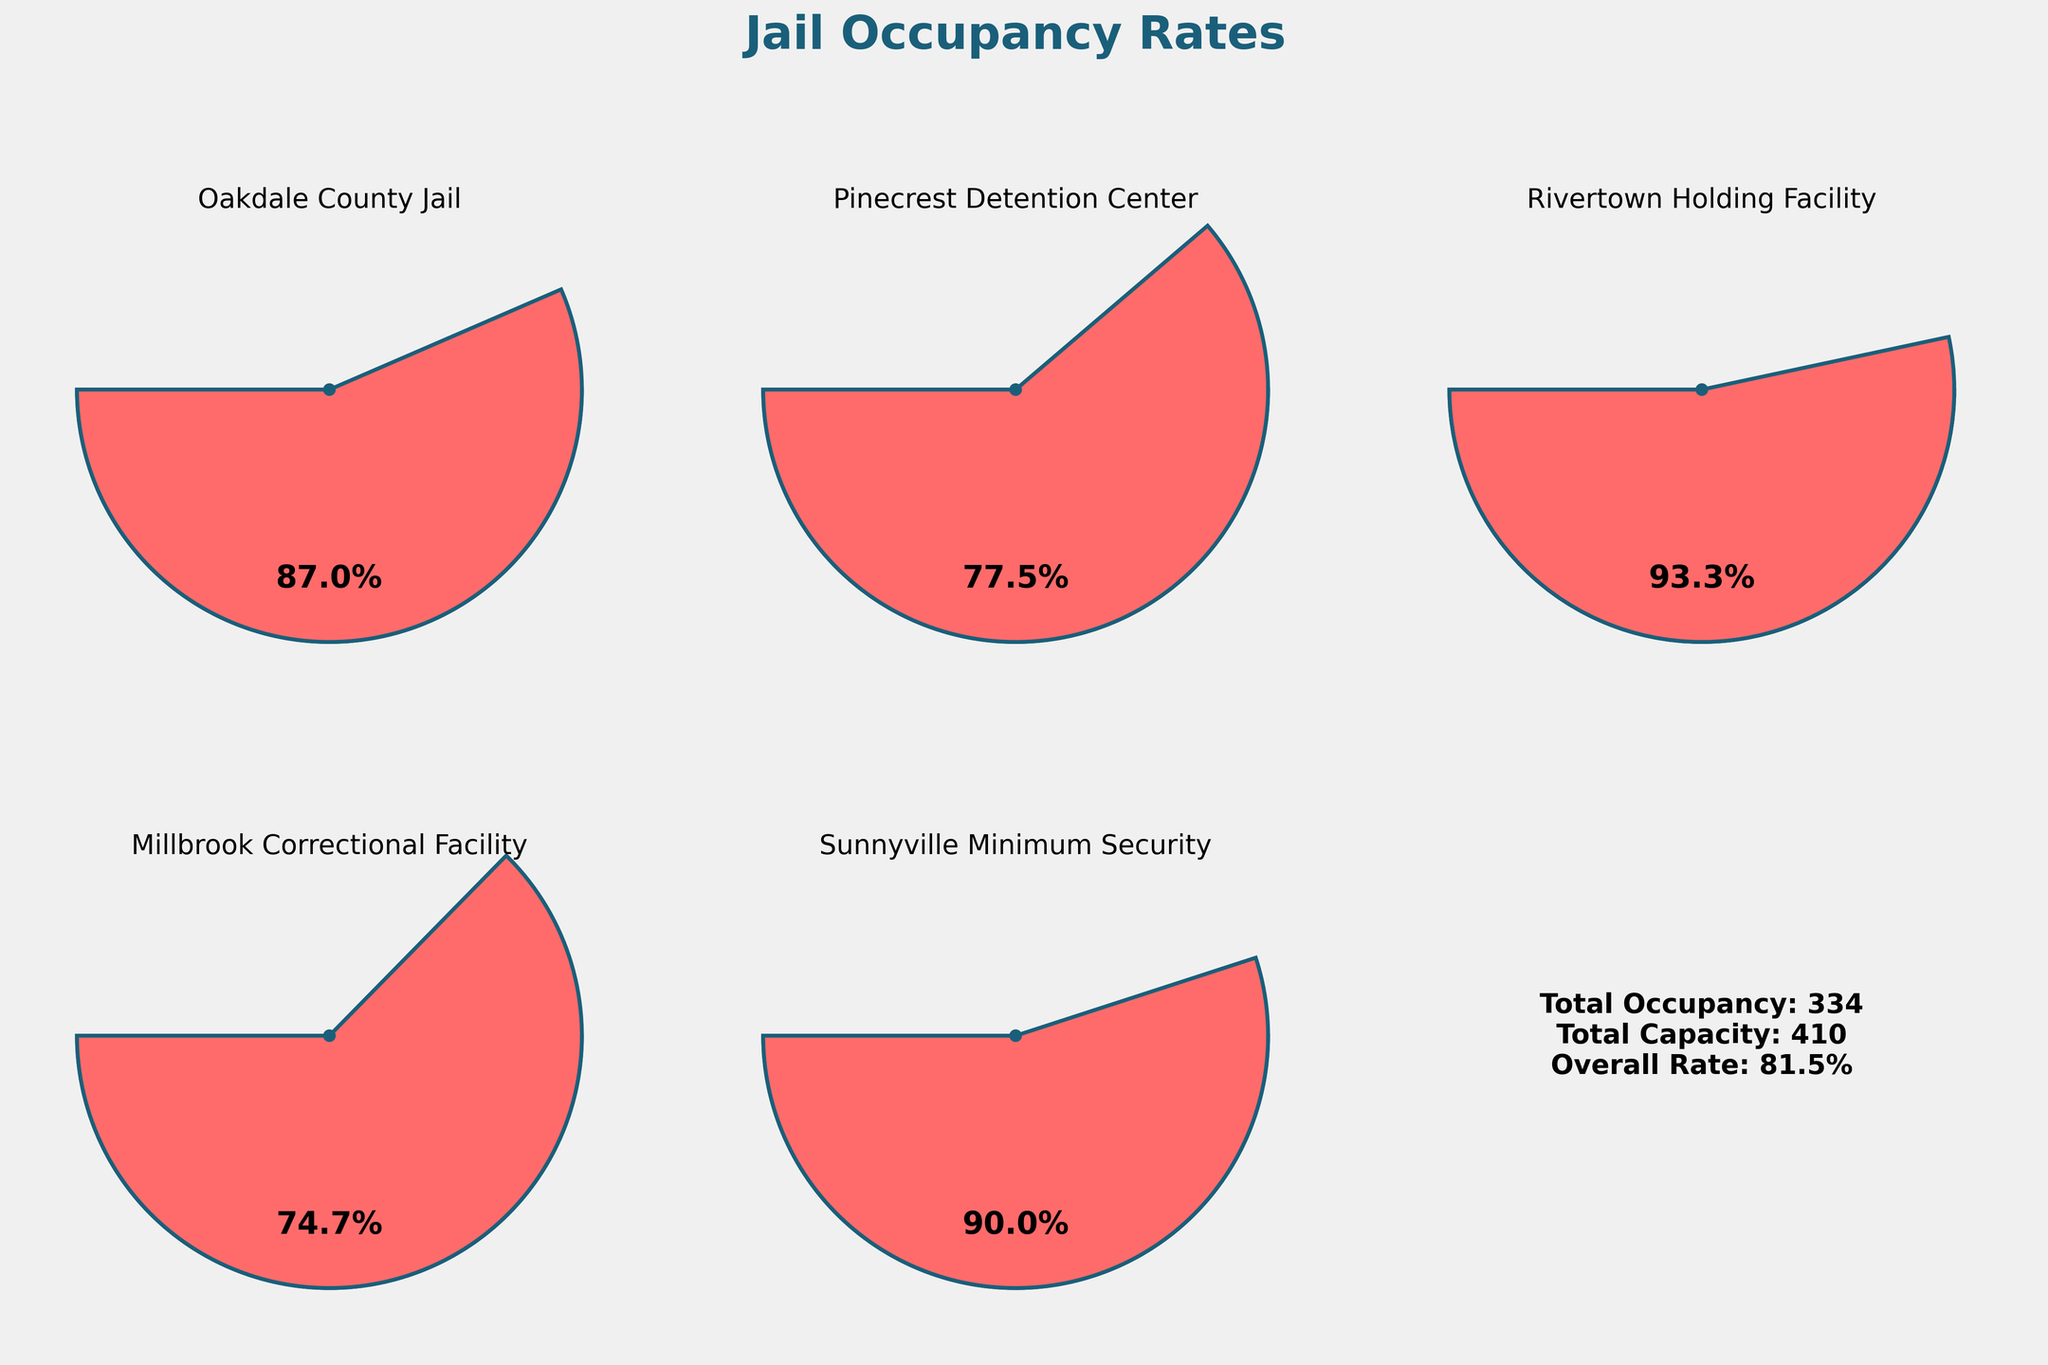What's the title of the figure? The title is typically found at the top of the figure. It is prominently displayed in bold and large font.
Answer: Jail Occupancy Rates Which facility has the highest occupancy rate? Look at the gauge charts and identify the one with the needle closest to the full capacity (100%). Rivertown Holding Facility has the needle closest to 100%.
Answer: Rivertown Holding Facility What's the overall occupancy rate across all facilities? The overall occupancy rate is given in the bottom right corner of the figure. It is calculated by the total occupancy divided by the total capacity times 100.
Answer: 82.6% Which facility has the lowest occupancy rate? Compare the values in each gauge chart and find the one that has the lowest percentage. Millbrook Correctional Facility shows the lowest occupancy rate.
Answer: Millbrook Correctional Facility What is the occupancy rate of Sunnyville Minimum Security? Locate the gauge chart for Sunnyville Minimum Security and read the percentage displayed inside the gauge.
Answer: 90% How many facilities have an occupancy rate greater than 80%? Count the number of gauges where the occupancy rate is above 80%. Three facilities exceed 80%: Oakdale County Jail, Rivertown Holding Facility, and Sunnyville Minimum Security.
Answer: 3 What is the total current occupancy across all facilities? Refer to the bottom right corner of the figure where the total current occupancy is listed.
Answer: 334 What’s the difference in occupancy rates between Millbrook Correctional Facility and Rivertown Holding Facility? Subtract the occupancy rate of Millbrook Correctional Facility (74.7%) from Rivertown Holding Facility (93.3%). 93.3 - 74.7 = 18.6.
Answer: 18.6% If Pinecrest Detention Center's capacity were increased by 20, what would its new occupancy rate be? First, new capacity = 80 + 20 = 100. Then, new occupancy rate = (Current Occupancy / New Capacity) * 100. So, (62 / 100) * 100 = 62%.
Answer: 62% Which facility is closest to its maximum capacity but has not reached it yet? Look for the facility with an occupancy rate less than but closest to 100%. Sunnyville Minimum Security at 90% is the closest to full without reaching it.
Answer: Sunnyville Minimum Security 